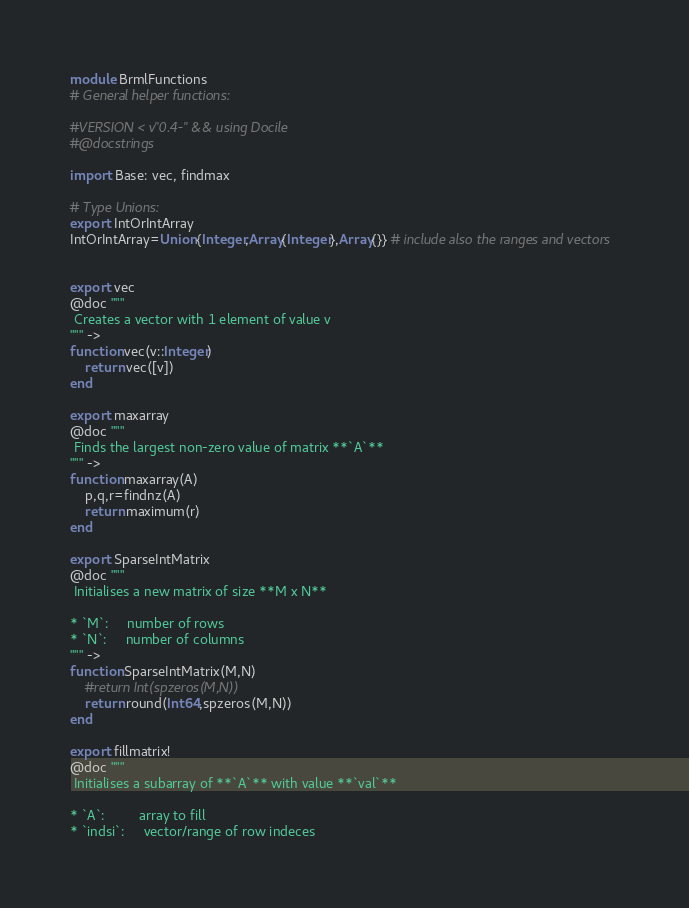<code> <loc_0><loc_0><loc_500><loc_500><_Julia_>
module BrmlFunctions
# General helper functions:

#VERSION < v"0.4-" && using Docile
#@docstrings

import Base: vec, findmax

# Type Unions:
export IntOrIntArray
IntOrIntArray=Union{Integer,Array{Integer},Array{}} # include also the ranges and vectors


export vec
@doc """
 Creates a vector with 1 element of value v
""" ->
function vec(v::Integer)
    return vec([v])
end

export maxarray
@doc """
 Finds the largest non-zero value of matrix **`A`**
""" ->
function maxarray(A)
    p,q,r=findnz(A)
    return maximum(r)
end

export SparseIntMatrix
@doc """
 Initialises a new matrix of size **M x N**

* `M`:     number of rows
* `N`:     number of columns
""" ->
function SparseIntMatrix(M,N)
    #return Int(spzeros(M,N))
    return round(Int64,spzeros(M,N))
end

export fillmatrix!
@doc """
 Initialises a subarray of **`A`** with value **`val`**

* `A`:         array to fill
* `indsi`:     vector/range of row indeces</code> 